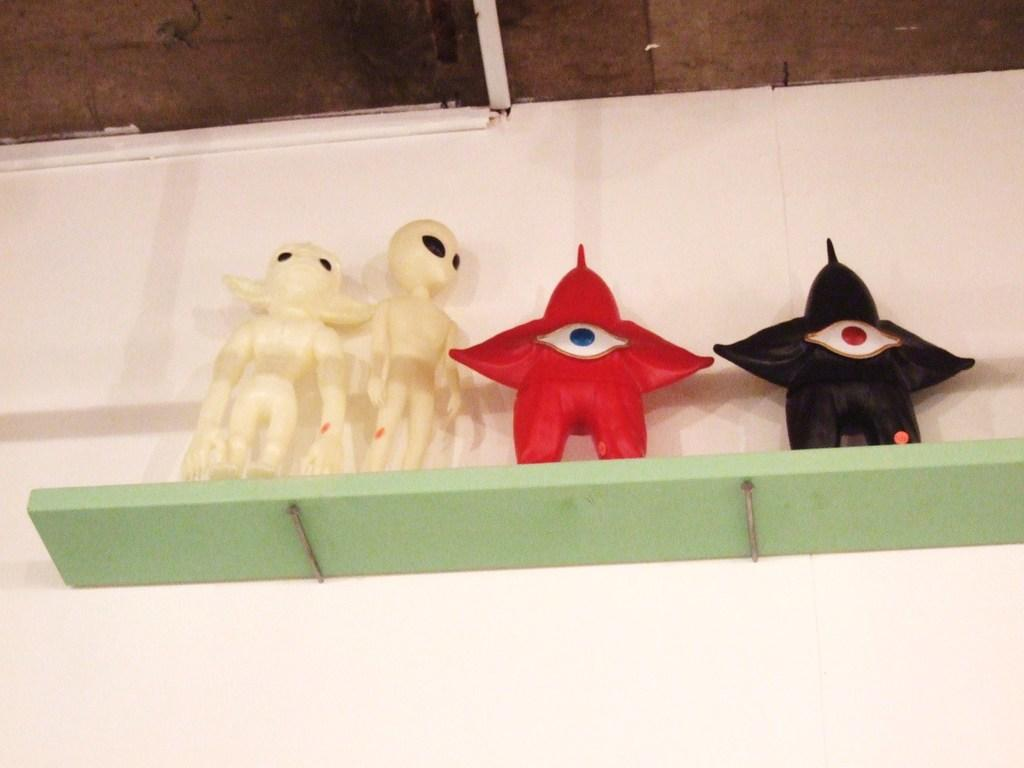What objects can be seen on a shelf in the image? There are toys on a shelf in the image. What else can be seen in the image besides the toys on the shelf? There is a wall visible in the image. What type of robin is sitting on the desk in the image? There is no robin or desk present in the image. What process is being carried out in the image? The image does not depict a process; it shows toys on a shelf and a wall. 